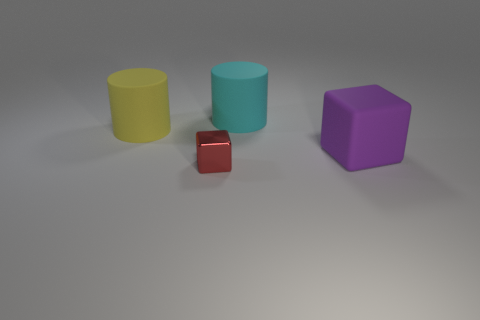Add 4 purple objects. How many objects exist? 8 Subtract 0 cyan blocks. How many objects are left? 4 Subtract all large rubber things. Subtract all big cyan things. How many objects are left? 0 Add 4 tiny objects. How many tiny objects are left? 5 Add 3 tiny purple cubes. How many tiny purple cubes exist? 3 